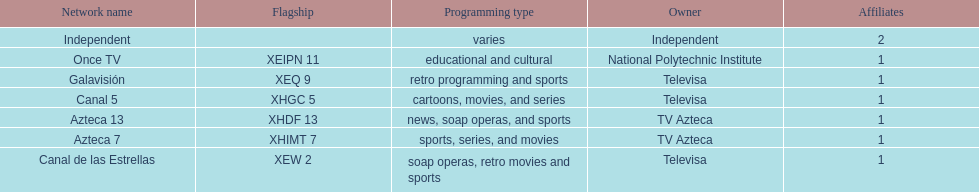How many networks refrain from airing sports content? 2. 